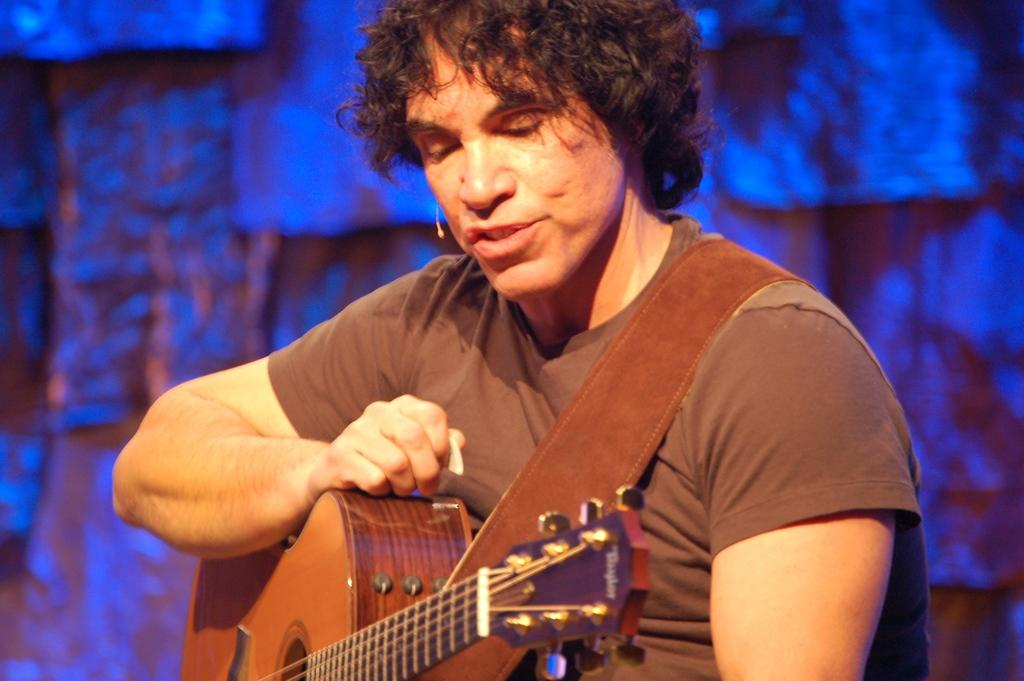What type of event is depicted in the image? The image is from a concert. What instrument is the man playing in the image? The man is playing a guitar in the image. What color is the shirt the man is wearing? The man is wearing a brown color shirt. What color is the background in the image? The background in the image is blue. How many oranges are visible on the guitar in the image? There are no oranges visible on the guitar in the image. What type of button is the man wearing on his shirt in the image? The man is not wearing a button on his shirt in the image; he is wearing a brown color shirt. 